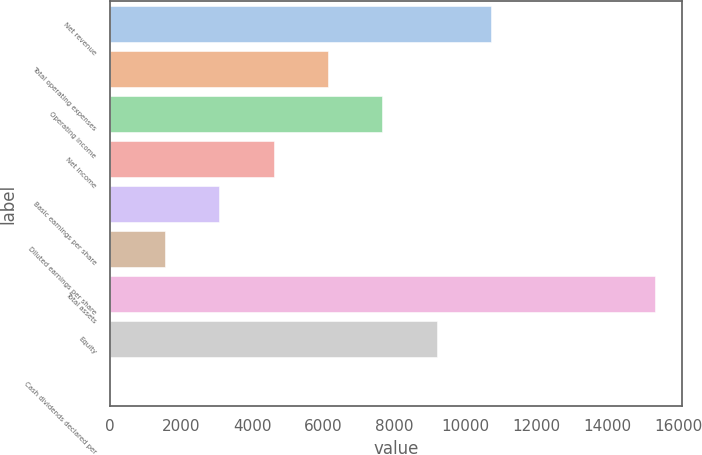<chart> <loc_0><loc_0><loc_500><loc_500><bar_chart><fcel>Net revenue<fcel>Total operating expenses<fcel>Operating income<fcel>Net income<fcel>Basic earnings per share<fcel>Diluted earnings per share<fcel>Total assets<fcel>Equity<fcel>Cash dividends declared per<nl><fcel>10730.4<fcel>6131.89<fcel>7664.74<fcel>4599.04<fcel>3066.19<fcel>1533.34<fcel>15329<fcel>9197.59<fcel>0.49<nl></chart> 